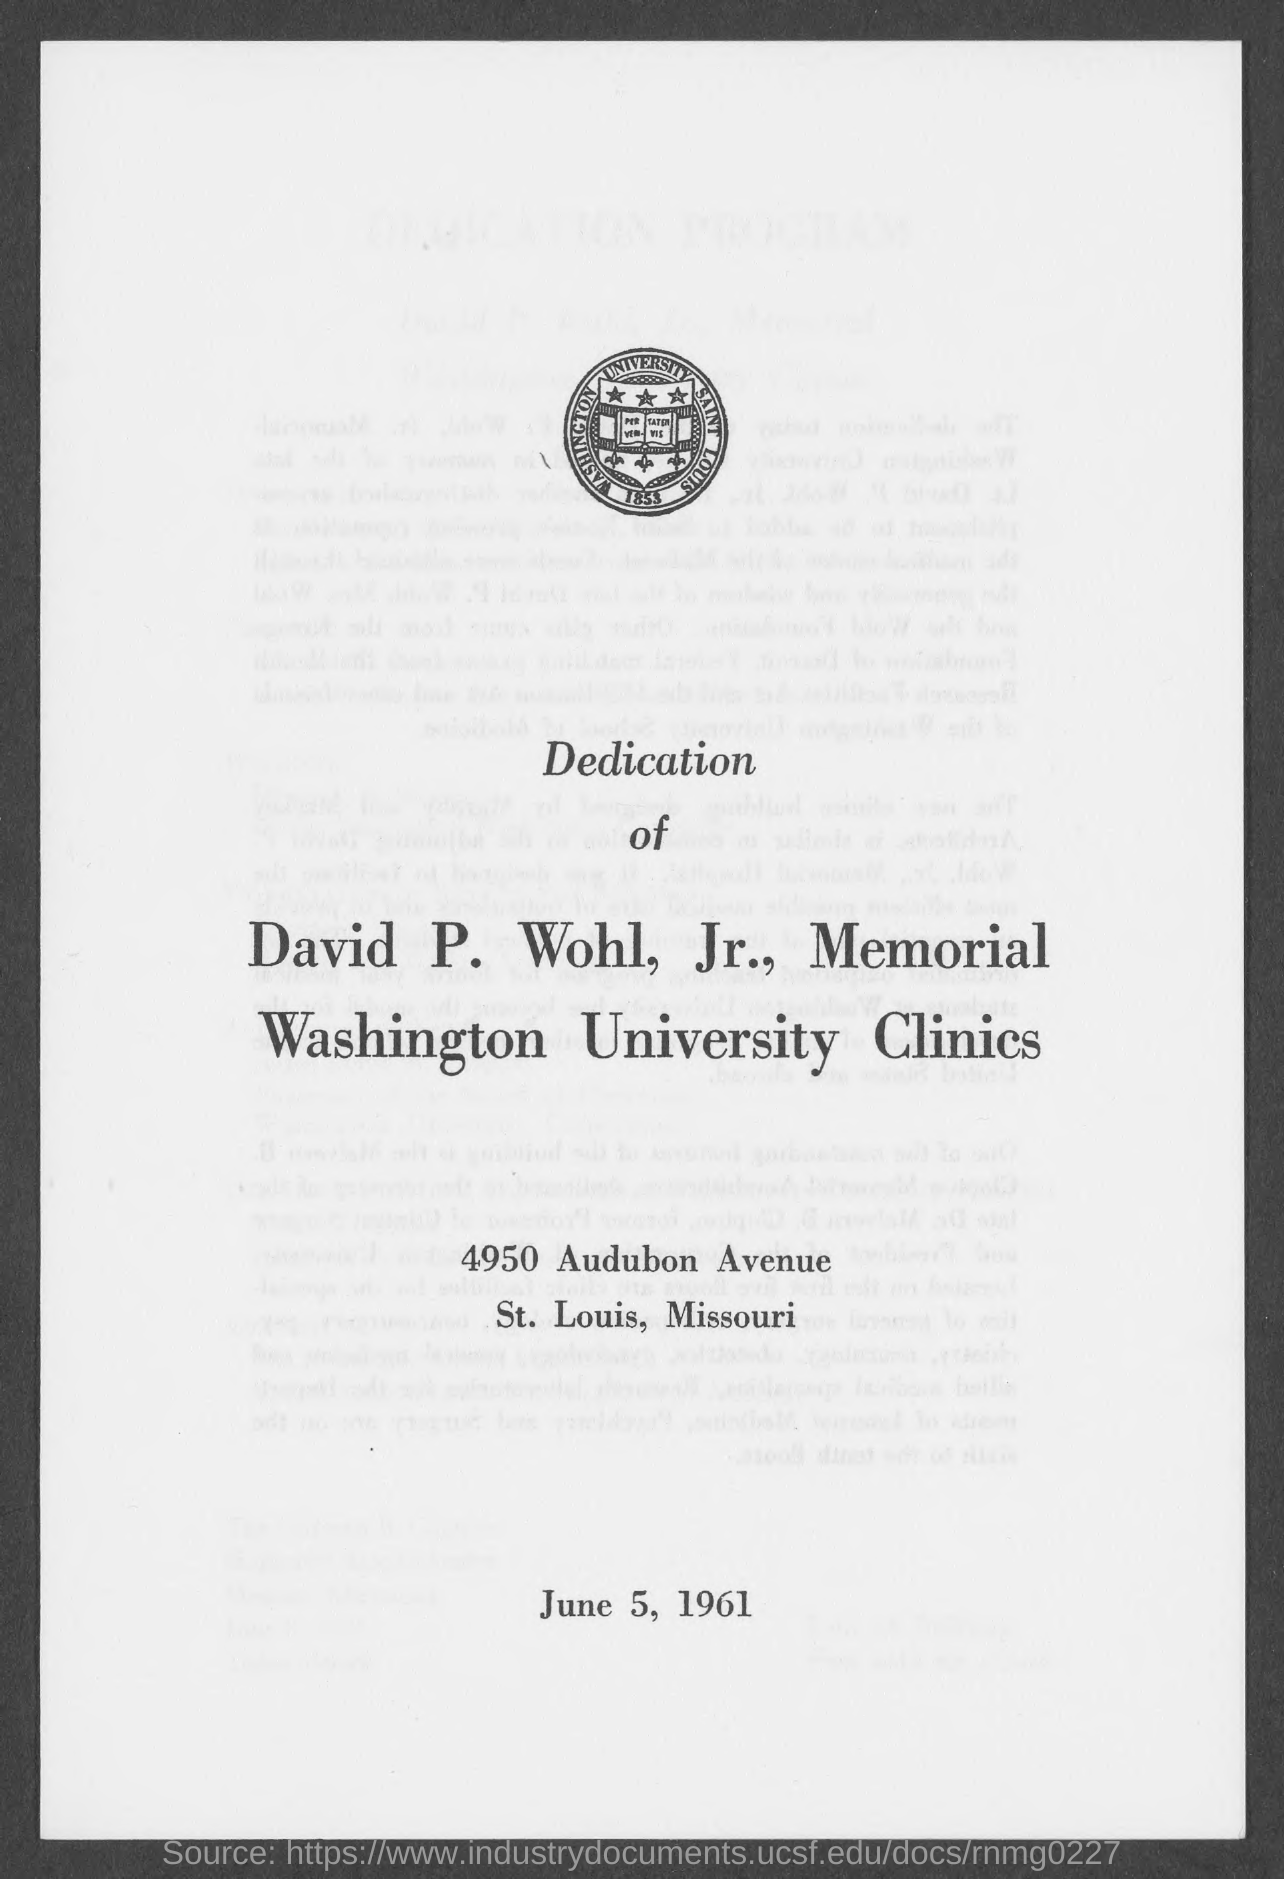What is the name of the university mentioned in the logo?
Provide a short and direct response. Washington university. 